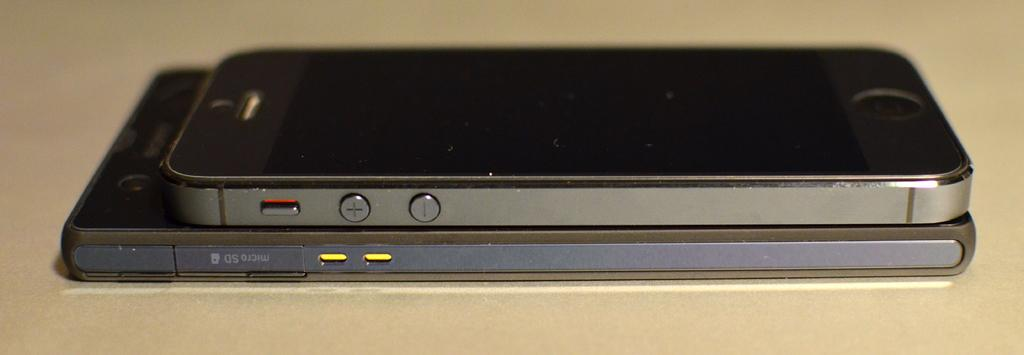What is the main subject of the image? The main subject of the image is a mobile placed on another mobile. How is the mobile positioned in the image? The mobile is placed on a surface. What is the color of the background in the image? The background of the image is cream in color. What type of liquid can be seen flowing from the monkey's mouth in the image? There is no monkey or liquid present in the image. 